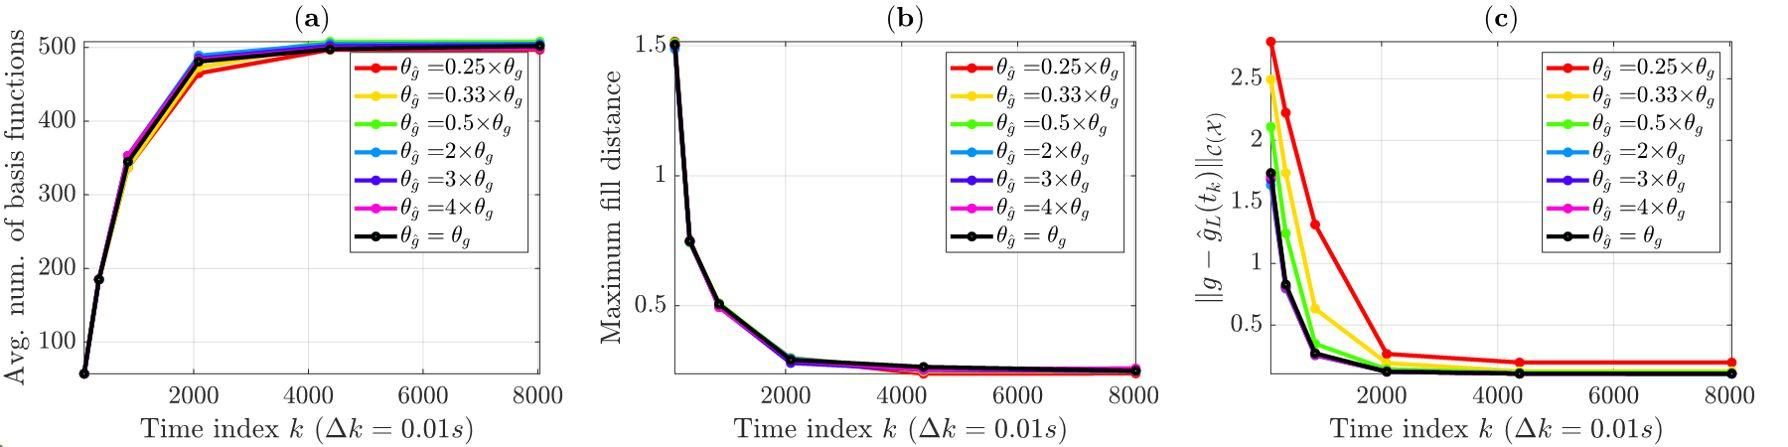What implications might the trends observed in figure (b) have for practical applications? The trends in figure (b), particularly the rapid decrease and subsequent stabilization of the maximum fill distance, could imply robustness in the system's performance after initial adjustments. In practical terms, this might suggest that once a system governed by such parameters reaches its steady state, it reliably maintains consistent behavior, which is valuable for applications requiring stability after set-up. 